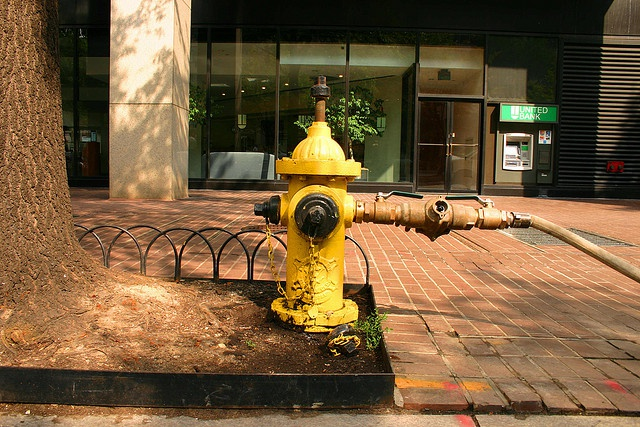Describe the objects in this image and their specific colors. I can see a fire hydrant in olive, orange, black, and gold tones in this image. 